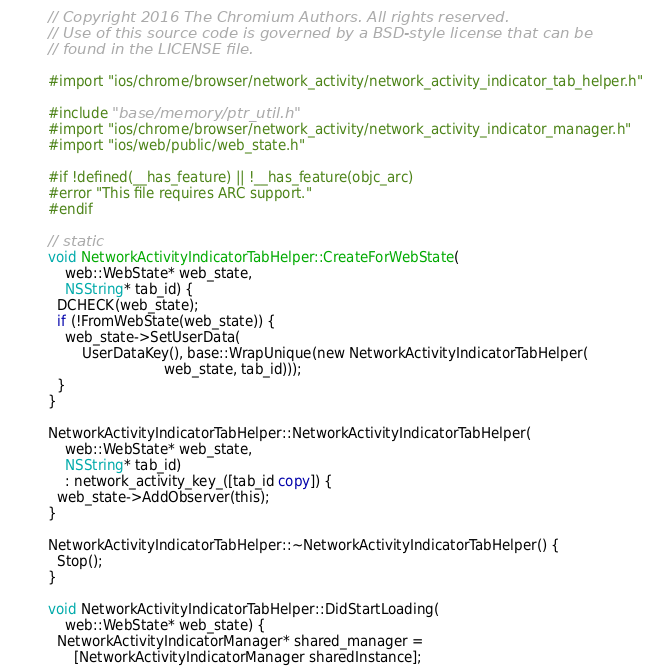Convert code to text. <code><loc_0><loc_0><loc_500><loc_500><_ObjectiveC_>// Copyright 2016 The Chromium Authors. All rights reserved.
// Use of this source code is governed by a BSD-style license that can be
// found in the LICENSE file.

#import "ios/chrome/browser/network_activity/network_activity_indicator_tab_helper.h"

#include "base/memory/ptr_util.h"
#import "ios/chrome/browser/network_activity/network_activity_indicator_manager.h"
#import "ios/web/public/web_state.h"

#if !defined(__has_feature) || !__has_feature(objc_arc)
#error "This file requires ARC support."
#endif

// static
void NetworkActivityIndicatorTabHelper::CreateForWebState(
    web::WebState* web_state,
    NSString* tab_id) {
  DCHECK(web_state);
  if (!FromWebState(web_state)) {
    web_state->SetUserData(
        UserDataKey(), base::WrapUnique(new NetworkActivityIndicatorTabHelper(
                           web_state, tab_id)));
  }
}

NetworkActivityIndicatorTabHelper::NetworkActivityIndicatorTabHelper(
    web::WebState* web_state,
    NSString* tab_id)
    : network_activity_key_([tab_id copy]) {
  web_state->AddObserver(this);
}

NetworkActivityIndicatorTabHelper::~NetworkActivityIndicatorTabHelper() {
  Stop();
}

void NetworkActivityIndicatorTabHelper::DidStartLoading(
    web::WebState* web_state) {
  NetworkActivityIndicatorManager* shared_manager =
      [NetworkActivityIndicatorManager sharedInstance];</code> 